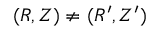<formula> <loc_0><loc_0><loc_500><loc_500>( R , Z ) \neq ( R ^ { \prime } , Z ^ { \prime } )</formula> 